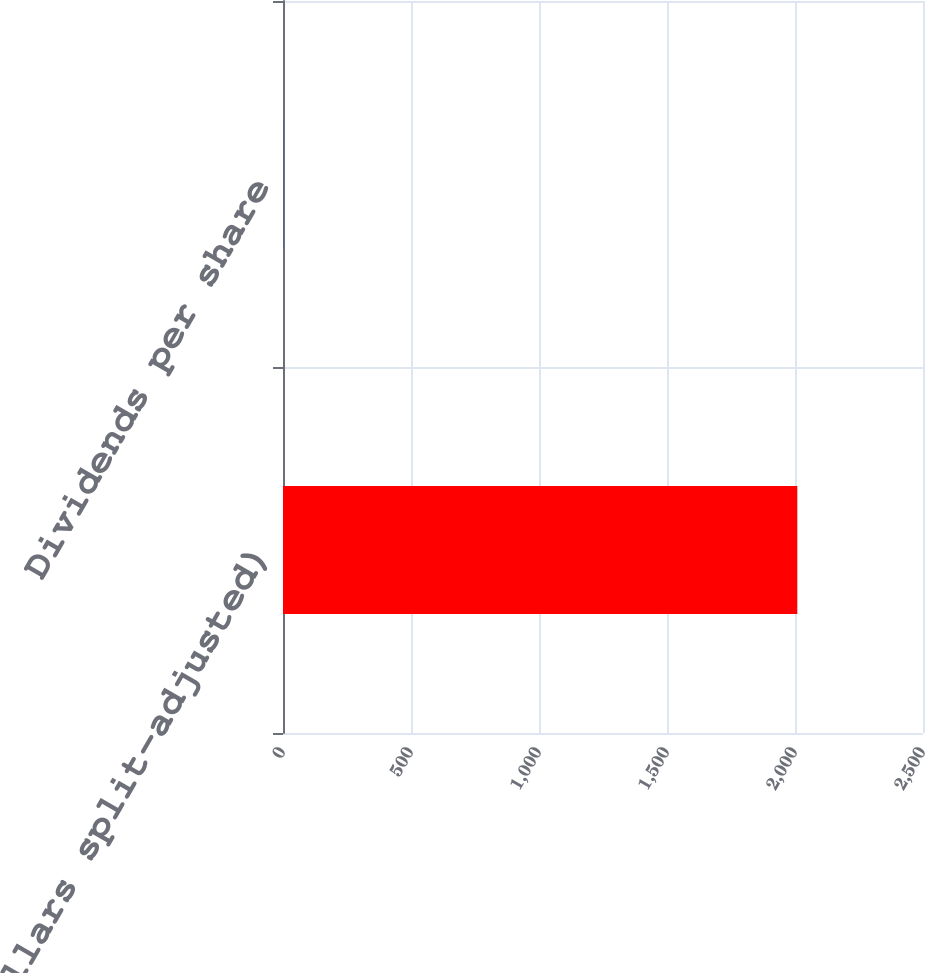<chart> <loc_0><loc_0><loc_500><loc_500><bar_chart><fcel>(in dollars split-adjusted)<fcel>Dividends per share<nl><fcel>2009<fcel>1.64<nl></chart> 